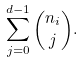<formula> <loc_0><loc_0><loc_500><loc_500>\sum _ { j = 0 } ^ { d - 1 } { n _ { i } \choose j } .</formula> 